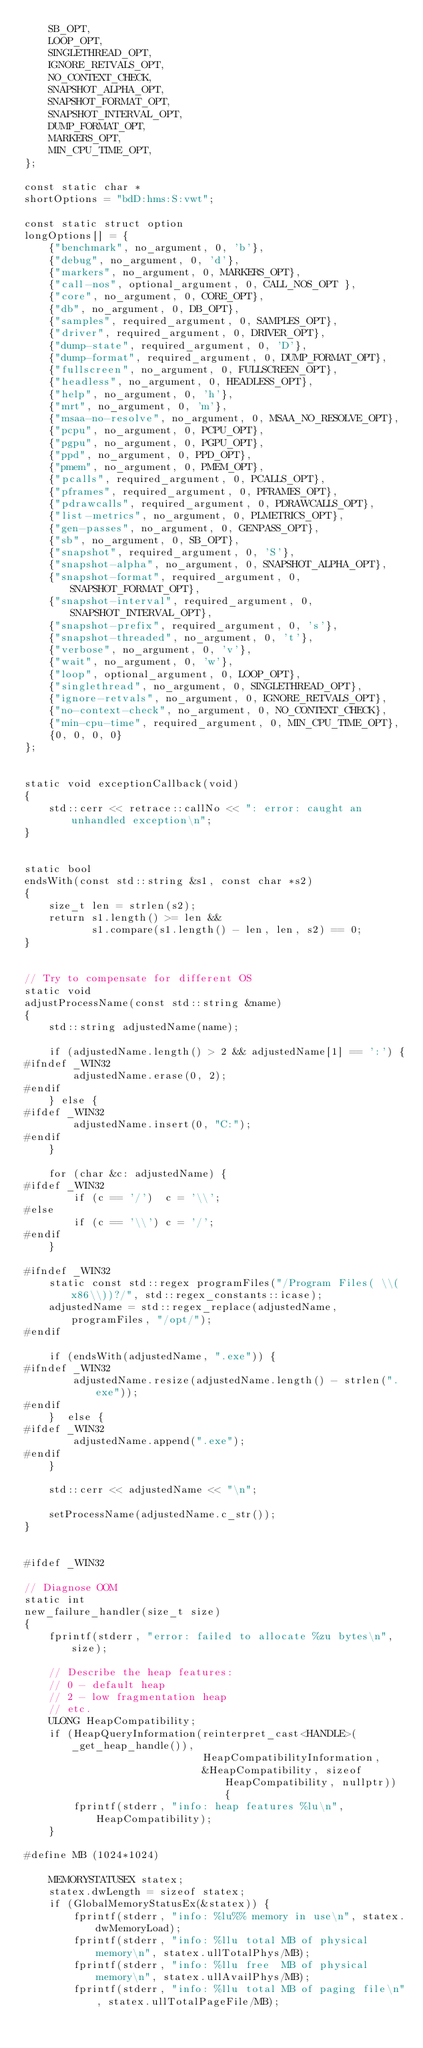<code> <loc_0><loc_0><loc_500><loc_500><_C++_>    SB_OPT,
    LOOP_OPT,
    SINGLETHREAD_OPT,
    IGNORE_RETVALS_OPT,
    NO_CONTEXT_CHECK,
    SNAPSHOT_ALPHA_OPT,
    SNAPSHOT_FORMAT_OPT,
    SNAPSHOT_INTERVAL_OPT,
    DUMP_FORMAT_OPT,
    MARKERS_OPT,
    MIN_CPU_TIME_OPT,
};

const static char *
shortOptions = "bdD:hms:S:vwt";

const static struct option
longOptions[] = {
    {"benchmark", no_argument, 0, 'b'},
    {"debug", no_argument, 0, 'd'},
    {"markers", no_argument, 0, MARKERS_OPT},
    {"call-nos", optional_argument, 0, CALL_NOS_OPT },
    {"core", no_argument, 0, CORE_OPT},
    {"db", no_argument, 0, DB_OPT},
    {"samples", required_argument, 0, SAMPLES_OPT},
    {"driver", required_argument, 0, DRIVER_OPT},
    {"dump-state", required_argument, 0, 'D'},
    {"dump-format", required_argument, 0, DUMP_FORMAT_OPT},
    {"fullscreen", no_argument, 0, FULLSCREEN_OPT},
    {"headless", no_argument, 0, HEADLESS_OPT},
    {"help", no_argument, 0, 'h'},
    {"mrt", no_argument, 0, 'm'},
    {"msaa-no-resolve", no_argument, 0, MSAA_NO_RESOLVE_OPT},
    {"pcpu", no_argument, 0, PCPU_OPT},
    {"pgpu", no_argument, 0, PGPU_OPT},
    {"ppd", no_argument, 0, PPD_OPT},
    {"pmem", no_argument, 0, PMEM_OPT},
    {"pcalls", required_argument, 0, PCALLS_OPT},
    {"pframes", required_argument, 0, PFRAMES_OPT},
    {"pdrawcalls", required_argument, 0, PDRAWCALLS_OPT},
    {"list-metrics", no_argument, 0, PLMETRICS_OPT},
    {"gen-passes", no_argument, 0, GENPASS_OPT},
    {"sb", no_argument, 0, SB_OPT},
    {"snapshot", required_argument, 0, 'S'},
    {"snapshot-alpha", no_argument, 0, SNAPSHOT_ALPHA_OPT},
    {"snapshot-format", required_argument, 0, SNAPSHOT_FORMAT_OPT},
    {"snapshot-interval", required_argument, 0, SNAPSHOT_INTERVAL_OPT},
    {"snapshot-prefix", required_argument, 0, 's'},
    {"snapshot-threaded", no_argument, 0, 't'},
    {"verbose", no_argument, 0, 'v'},
    {"wait", no_argument, 0, 'w'},
    {"loop", optional_argument, 0, LOOP_OPT},
    {"singlethread", no_argument, 0, SINGLETHREAD_OPT},
    {"ignore-retvals", no_argument, 0, IGNORE_RETVALS_OPT},
    {"no-context-check", no_argument, 0, NO_CONTEXT_CHECK},
    {"min-cpu-time", required_argument, 0, MIN_CPU_TIME_OPT},
    {0, 0, 0, 0}
};


static void exceptionCallback(void)
{
    std::cerr << retrace::callNo << ": error: caught an unhandled exception\n";
}


static bool
endsWith(const std::string &s1, const char *s2)
{
    size_t len = strlen(s2);
    return s1.length() >= len &&
           s1.compare(s1.length() - len, len, s2) == 0;
}


// Try to compensate for different OS
static void
adjustProcessName(const std::string &name)
{
    std::string adjustedName(name);

    if (adjustedName.length() > 2 && adjustedName[1] == ':') {
#ifndef _WIN32
        adjustedName.erase(0, 2);
#endif
    } else {
#ifdef _WIN32
        adjustedName.insert(0, "C:");
#endif
    }

    for (char &c: adjustedName) {
#ifdef _WIN32
        if (c == '/')  c = '\\';
#else
        if (c == '\\') c = '/';
#endif
    }

#ifndef _WIN32
    static const std::regex programFiles("/Program Files( \\(x86\\))?/", std::regex_constants::icase);
    adjustedName = std::regex_replace(adjustedName, programFiles, "/opt/");
#endif

    if (endsWith(adjustedName, ".exe")) {
#ifndef _WIN32
        adjustedName.resize(adjustedName.length() - strlen(".exe"));
#endif
    }  else {
#ifdef _WIN32
        adjustedName.append(".exe");
#endif
    }

    std::cerr << adjustedName << "\n";

    setProcessName(adjustedName.c_str());
}


#ifdef _WIN32

// Diagnose OOM
static int
new_failure_handler(size_t size)
{
    fprintf(stderr, "error: failed to allocate %zu bytes\n", size);

    // Describe the heap features:
    // 0 - default heap
    // 2 - low fragmentation heap
    // etc.
    ULONG HeapCompatibility;
    if (HeapQueryInformation(reinterpret_cast<HANDLE>(_get_heap_handle()),
                             HeapCompatibilityInformation,
                             &HeapCompatibility, sizeof HeapCompatibility, nullptr)) {
        fprintf(stderr, "info: heap features %lu\n", HeapCompatibility);
    }

#define MB (1024*1024)

    MEMORYSTATUSEX statex;
    statex.dwLength = sizeof statex;
    if (GlobalMemoryStatusEx(&statex)) {
        fprintf(stderr, "info: %lu%% memory in use\n", statex.dwMemoryLoad);
        fprintf(stderr, "info: %llu total MB of physical memory\n", statex.ullTotalPhys/MB);
        fprintf(stderr, "info: %llu free  MB of physical memory\n", statex.ullAvailPhys/MB);
        fprintf(stderr, "info: %llu total MB of paging file\n", statex.ullTotalPageFile/MB);</code> 